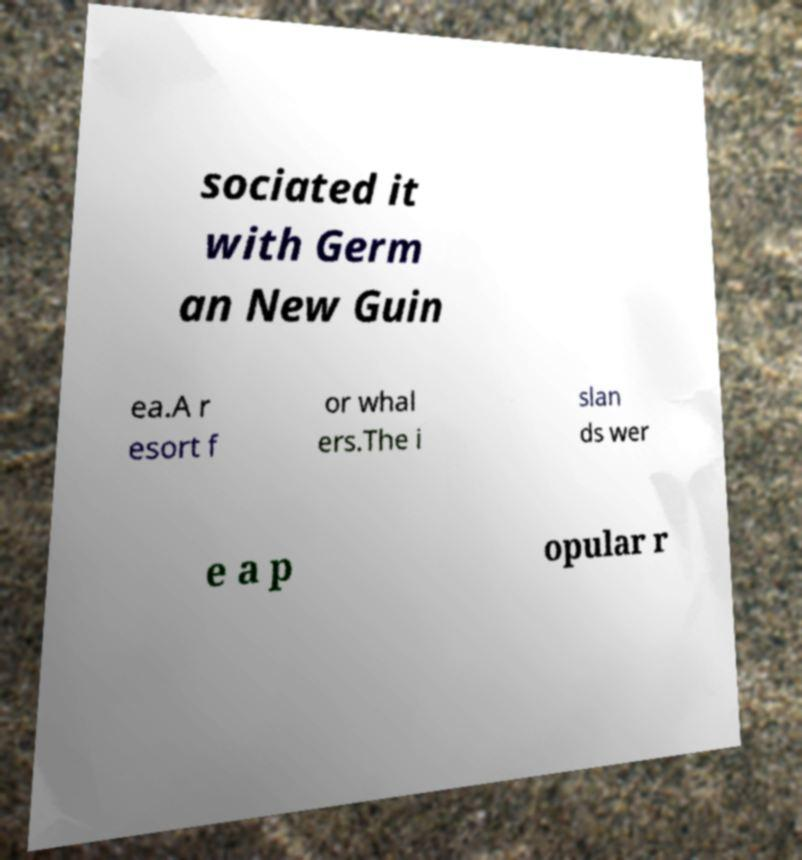Can you accurately transcribe the text from the provided image for me? sociated it with Germ an New Guin ea.A r esort f or whal ers.The i slan ds wer e a p opular r 